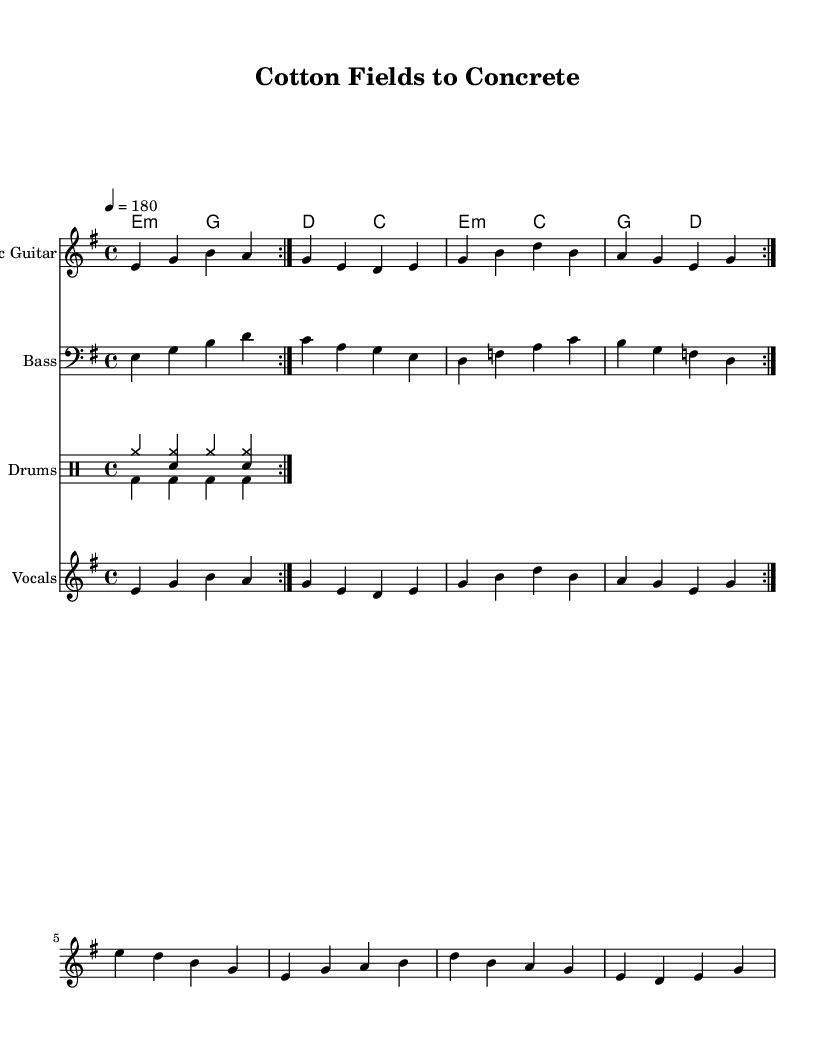What is the key signature of this music? The key signature is E minor, which has one sharp (F#). This is indicated at the beginning of the staff where the key signature is shown.
Answer: E minor What is the time signature of this music? The time signature is 4/4, which means there are four beats in each measure. This is shown at the beginning of the score next to the key signature.
Answer: 4/4 What is the tempo marking of this piece? The tempo marking is quarter note equals 180, meaning the piece is performed at a fast pace of 180 beats per minute. This is indicated in the tempo marking at the beginning of the score.
Answer: 180 How many measures are repeated in the electric guitar part? The electric guitar part has a repeat of 2 measures, which is indicated by the use of "volta" markings in the notation.
Answer: 2 measures What instruments are featured in this arrangement? The arrangement features Electric Guitar, Bass, Drums, and Vocals. This can be seen with the instrument names listed at the beginning of each staff in the score.
Answer: Electric Guitar, Bass, Drums, Vocals What type of harmony is present in the piece? The harmony is based on triads typical of jazz and blues, often using seventh chords which create a richer sound. The chord names written above the staff provide this harmonic structure.
Answer: Triads and seventh chords What lyrical theme does this song suggest? The lyrics focus on the theme of migration from rural to urban life, as seen in the phrase "Cotton fields to concrete." This reflects the historical context of the Great Migration.
Answer: Migration from rural to urban 